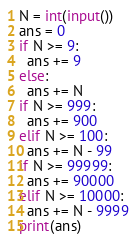Convert code to text. <code><loc_0><loc_0><loc_500><loc_500><_Python_>N = int(input())
ans = 0
if N >= 9:
  ans += 9
else:
  ans += N
if N >= 999:
  ans += 900
elif N >= 100:
  ans += N - 99
if N >= 99999:
  ans += 90000
elif N >= 10000:
  ans += N - 9999
print(ans)</code> 